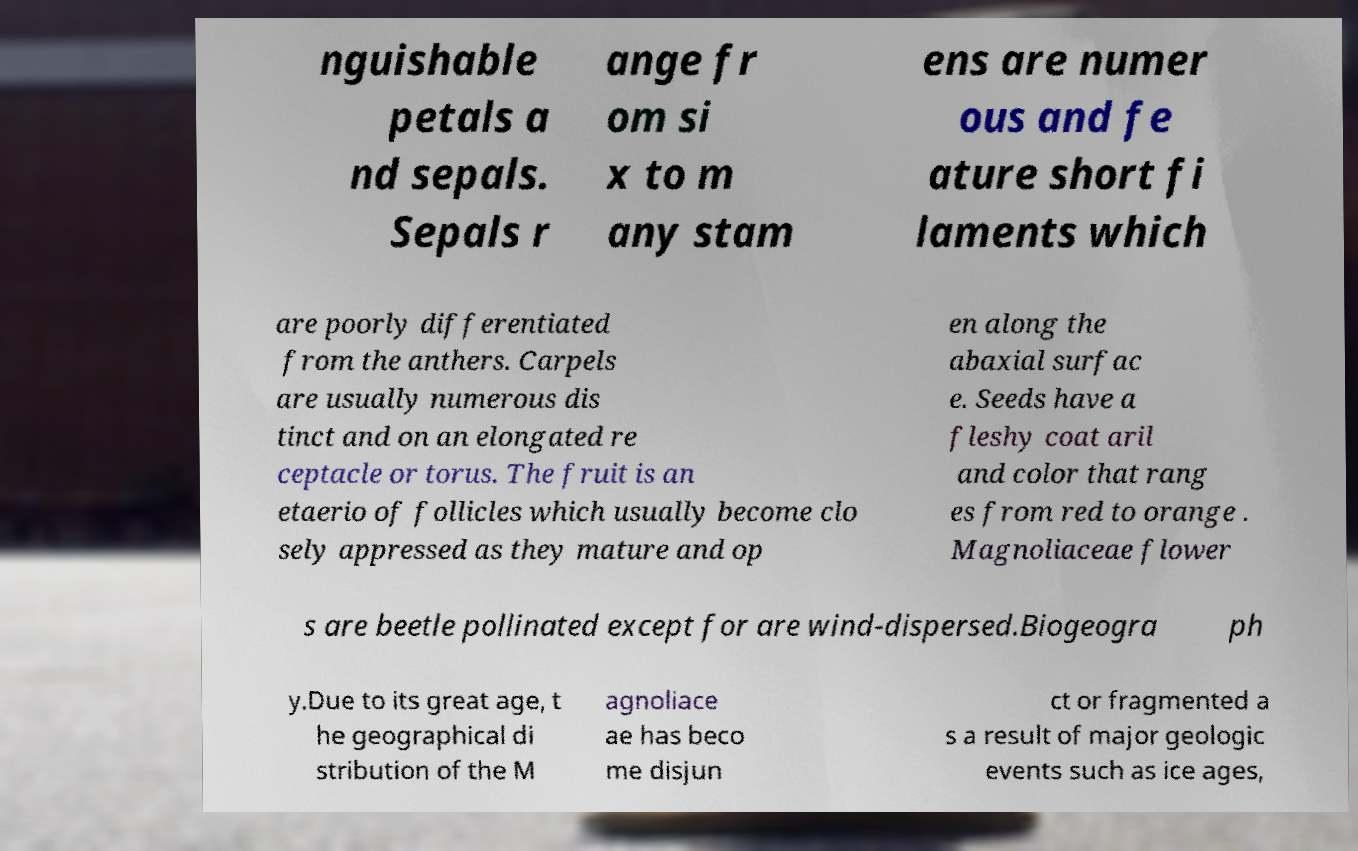Please identify and transcribe the text found in this image. nguishable petals a nd sepals. Sepals r ange fr om si x to m any stam ens are numer ous and fe ature short fi laments which are poorly differentiated from the anthers. Carpels are usually numerous dis tinct and on an elongated re ceptacle or torus. The fruit is an etaerio of follicles which usually become clo sely appressed as they mature and op en along the abaxial surfac e. Seeds have a fleshy coat aril and color that rang es from red to orange . Magnoliaceae flower s are beetle pollinated except for are wind-dispersed.Biogeogra ph y.Due to its great age, t he geographical di stribution of the M agnoliace ae has beco me disjun ct or fragmented a s a result of major geologic events such as ice ages, 